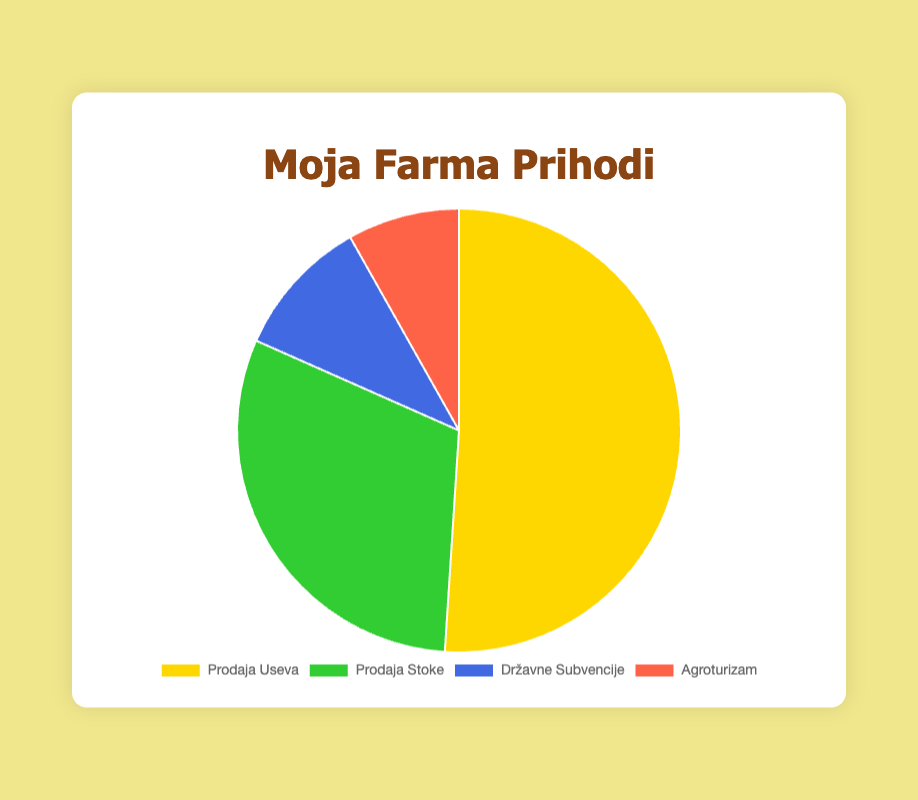Which source of income contributes the most to the farm income? By visually analyzing the pie chart, we see that the largest segment represents Crop Sales, indicating it's the biggest contributor.
Answer: Crop Sales Which source of income contributes the least to the farm income? The smallest segment in the pie chart corresponds to Agritourism, confirming it's the smallest contributor.
Answer: Agritourism What is the total income from Livestock Sales and Government Subsidies? The pie chart shows Livestock Sales amounting to 30,000 RSD and Government Subsidies amounting to 10,000 RSD. Adding them together gives 30,000 + 10,000 = 40,000 RSD.
Answer: 40,000 RSD What fraction of the total farm income comes from Crop Sales? The total income from all sources is 50,000 + 30,000 + 10,000 + 8,000 = 98,000 RSD. The fraction from Crop Sales is 50,000 / 98,000 ≈ 0.51 or 51%.
Answer: 51% Which source has a larger income, Government Subsidies or Agritourism? The pie chart shows that Government Subsidies amount to 10,000 RSD and Agritourism amounts to 8,000 RSD. Government Subsidies is larger.
Answer: Government Subsidies How much more income does Crop Sales generate compared to Livestock Sales? From the pie chart, Crop Sales generate 50,000 RSD and Livestock Sales generate 30,000 RSD. The difference is 50,000 - 30,000 = 20,000 RSD.
Answer: 20,000 RSD What percentage of the total farm income is generated by Livestock Sales? The total income is 98,000 RSD. The income from Livestock Sales is 30,000 RSD. The percentage is (30,000 / 98,000) * 100 ≈ 30.61%.
Answer: 30.61% Combine the income from Government Subsidies and Agritourism, then find how much income Crop Sales exceed this combined amount. Government Subsidies and Agritourism together make 10,000 + 8,000 = 18,000 RSD. Crop Sales are 50,000 RSD. The difference is 50,000 - 18,000 = 32,000 RSD.
Answer: 32,000 RSD What is the average income from all sources? The total income is 98,000 RSD, distributed among 4 sources. The average income is 98,000 / 4 = 24,500 RSD.
Answer: 24,500 RSD 